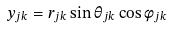Convert formula to latex. <formula><loc_0><loc_0><loc_500><loc_500>y _ { j k } = r _ { j k } \sin { \theta _ { j k } } \cos { \phi _ { j k } }</formula> 